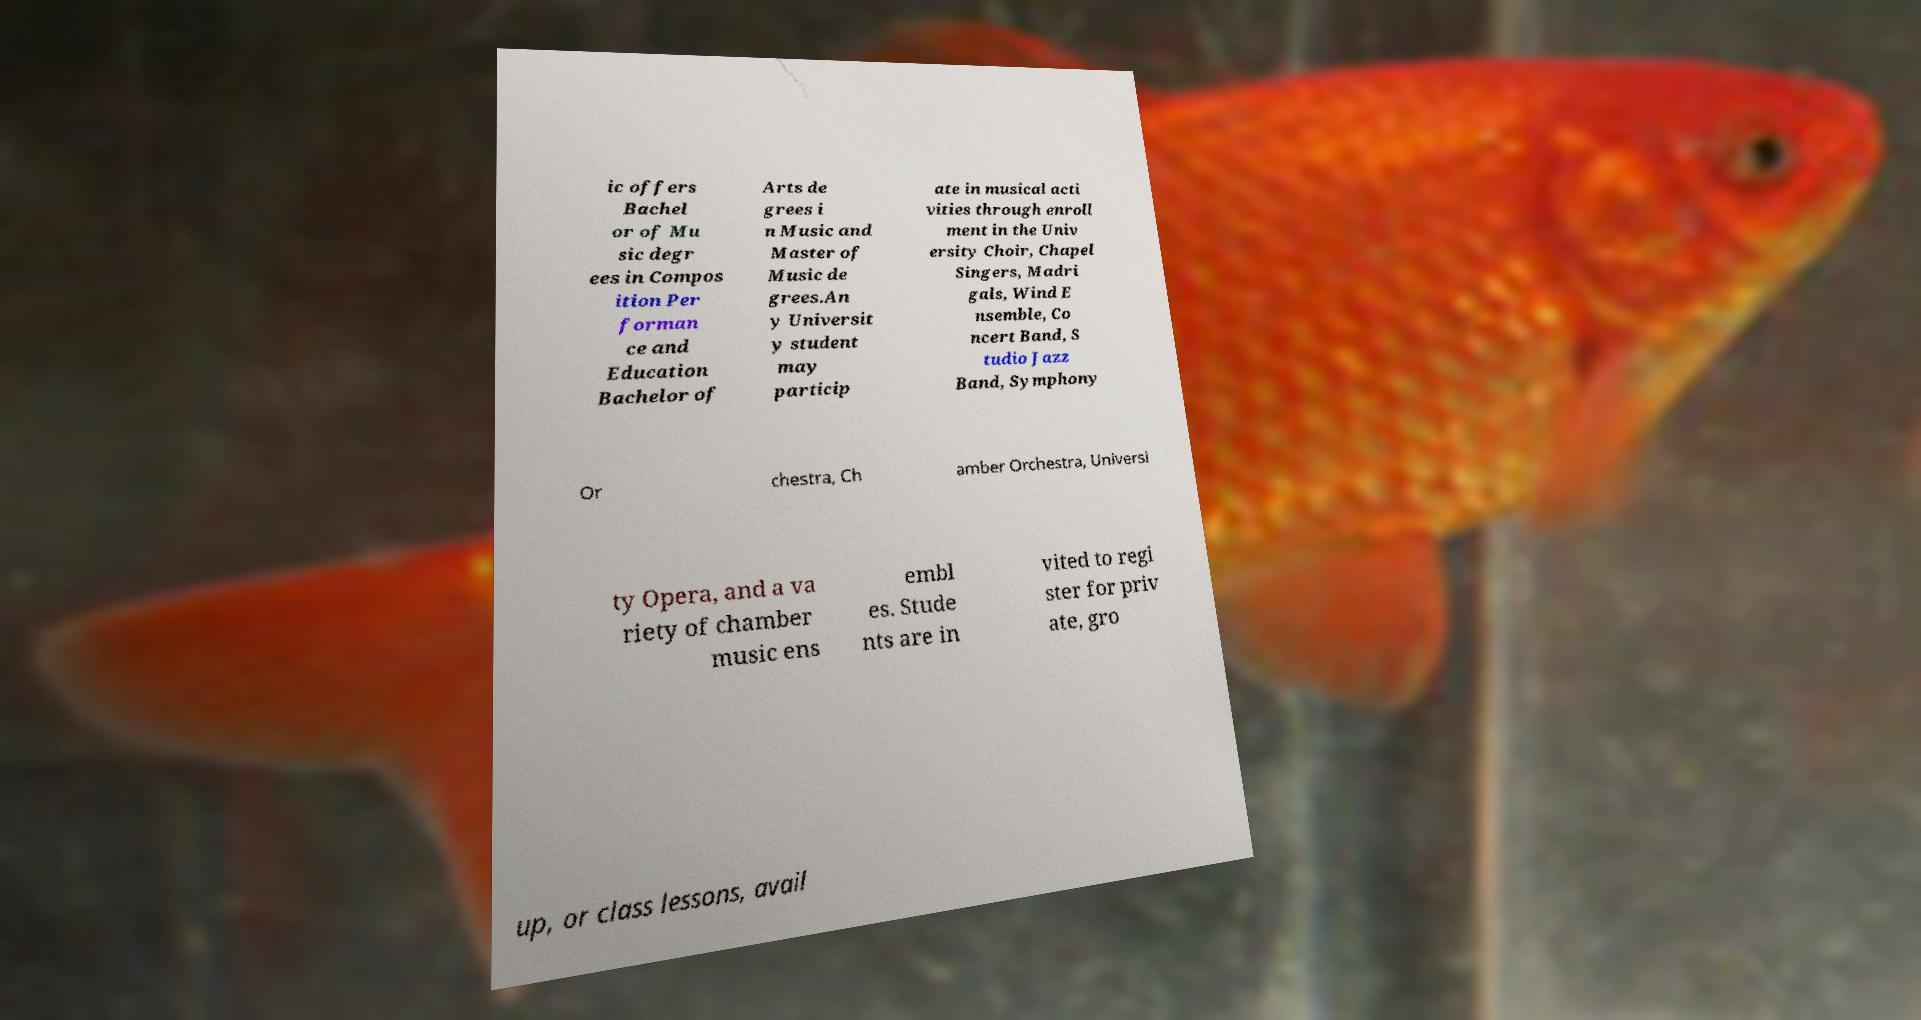Can you read and provide the text displayed in the image?This photo seems to have some interesting text. Can you extract and type it out for me? ic offers Bachel or of Mu sic degr ees in Compos ition Per forman ce and Education Bachelor of Arts de grees i n Music and Master of Music de grees.An y Universit y student may particip ate in musical acti vities through enroll ment in the Univ ersity Choir, Chapel Singers, Madri gals, Wind E nsemble, Co ncert Band, S tudio Jazz Band, Symphony Or chestra, Ch amber Orchestra, Universi ty Opera, and a va riety of chamber music ens embl es. Stude nts are in vited to regi ster for priv ate, gro up, or class lessons, avail 